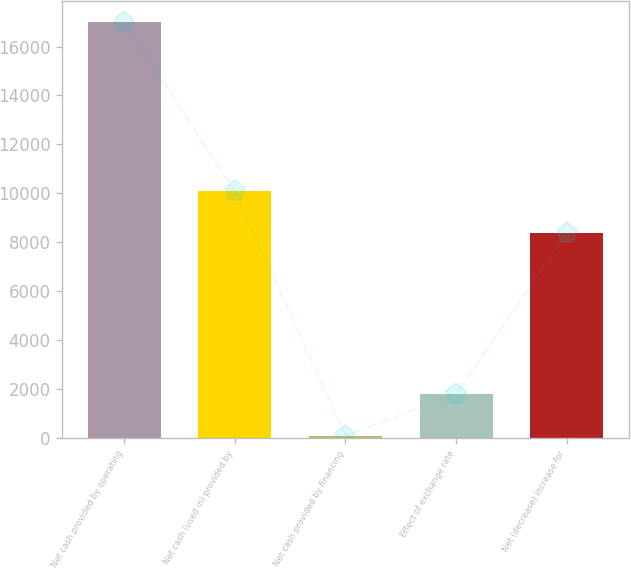<chart> <loc_0><loc_0><loc_500><loc_500><bar_chart><fcel>Net cash provided by operating<fcel>Net cash (used in) provided by<fcel>Net cash provided by financing<fcel>Effect of exchange rate<fcel>Net (decrease) increase for<nl><fcel>17022<fcel>10069.2<fcel>80<fcel>1774.2<fcel>8375<nl></chart> 